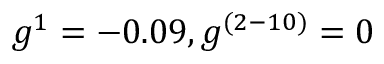<formula> <loc_0><loc_0><loc_500><loc_500>g ^ { 1 } = - 0 . 0 9 , g ^ { ( 2 - 1 0 ) } = 0</formula> 